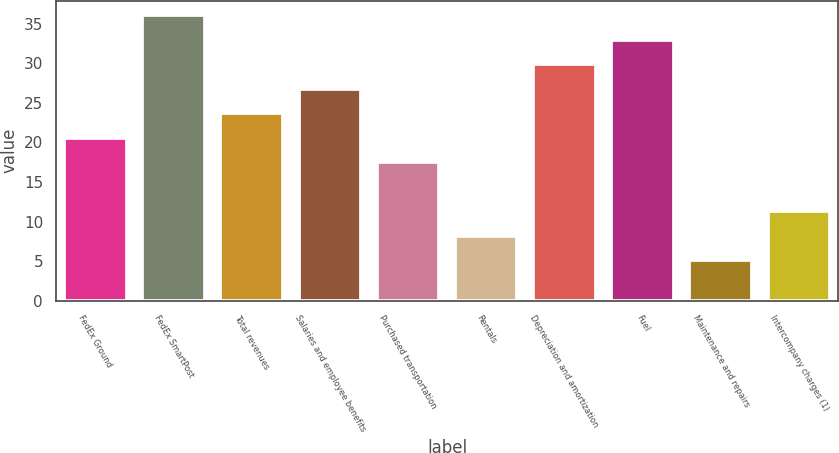<chart> <loc_0><loc_0><loc_500><loc_500><bar_chart><fcel>FedEx Ground<fcel>FedEx SmartPost<fcel>Total revenues<fcel>Salaries and employee benefits<fcel>Purchased transportation<fcel>Rentals<fcel>Depreciation and amortization<fcel>Fuel<fcel>Maintenance and repairs<fcel>Intercompany charges (1)<nl><fcel>20.6<fcel>36.1<fcel>23.7<fcel>26.8<fcel>17.5<fcel>8.2<fcel>29.9<fcel>33<fcel>5.1<fcel>11.3<nl></chart> 